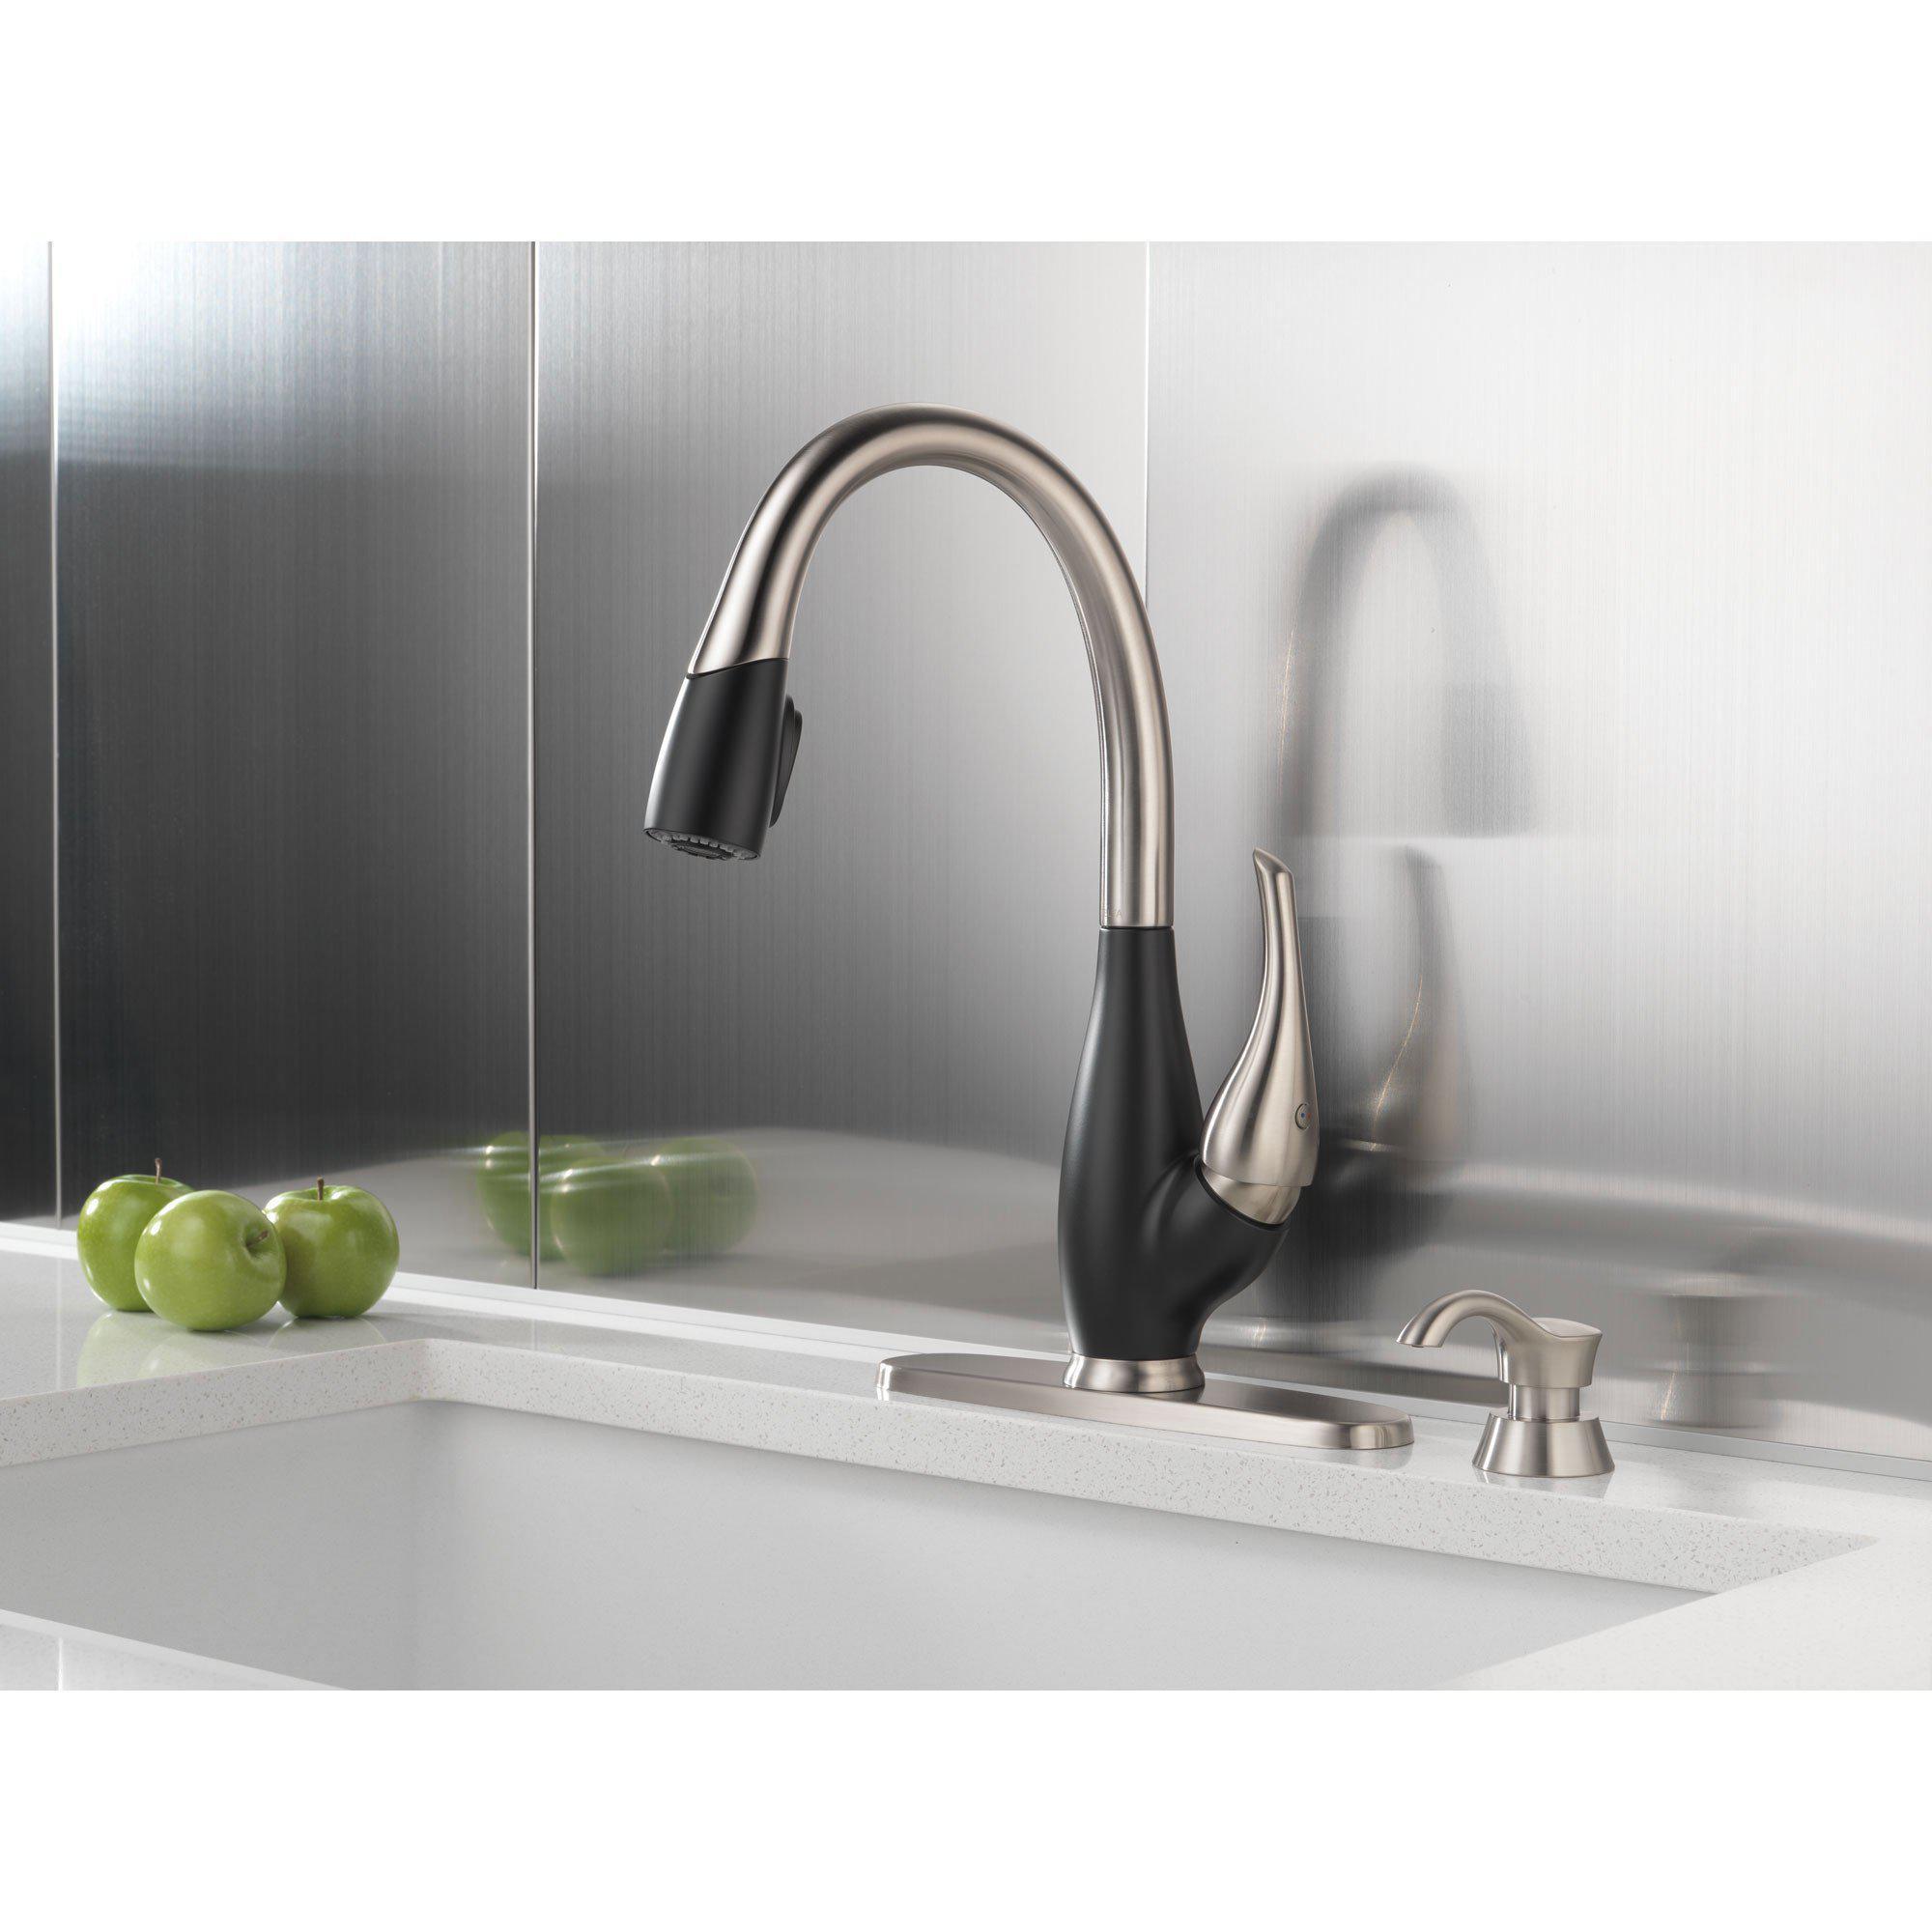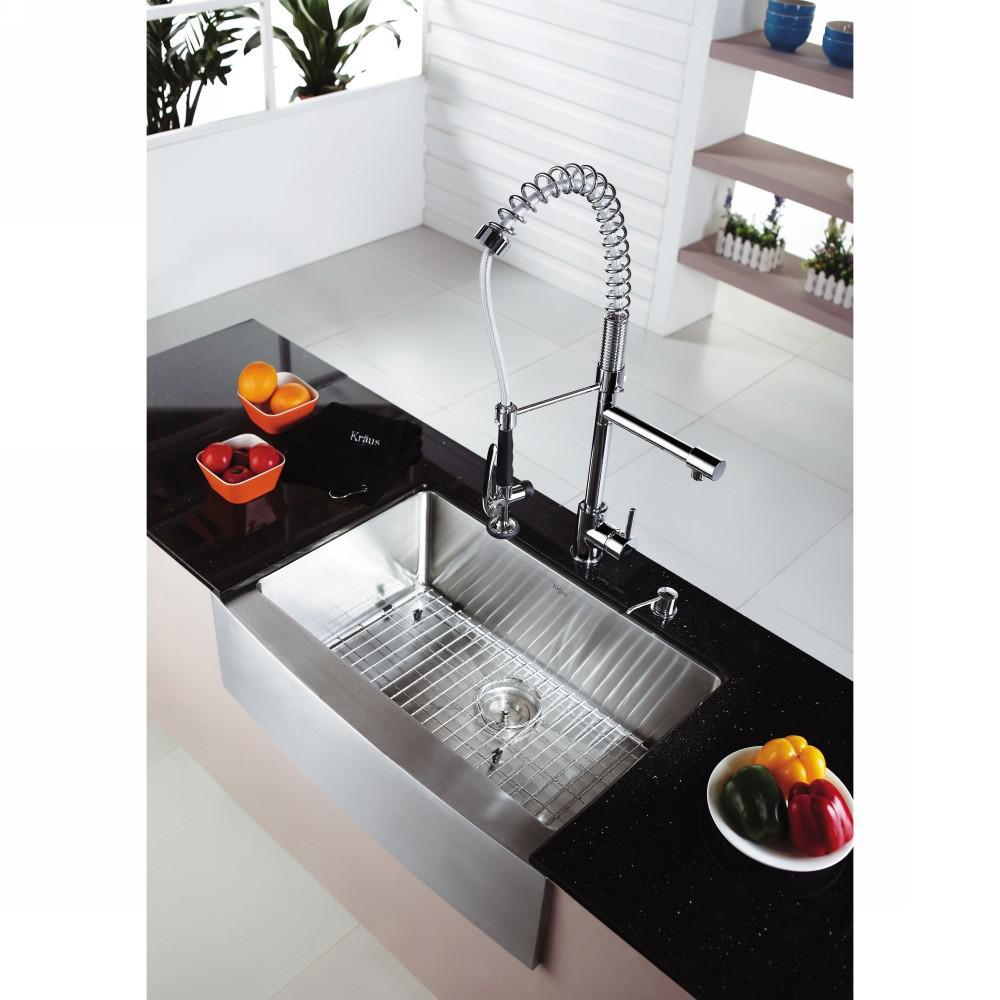The first image is the image on the left, the second image is the image on the right. For the images displayed, is the sentence "The sink in the image on the right has a double basin." factually correct? Answer yes or no. No. The first image is the image on the left, the second image is the image on the right. Analyze the images presented: Is the assertion "An image shows a single-basin steel sink with a wire rack insert, inset in a gray swirl marble counter." valid? Answer yes or no. No. 